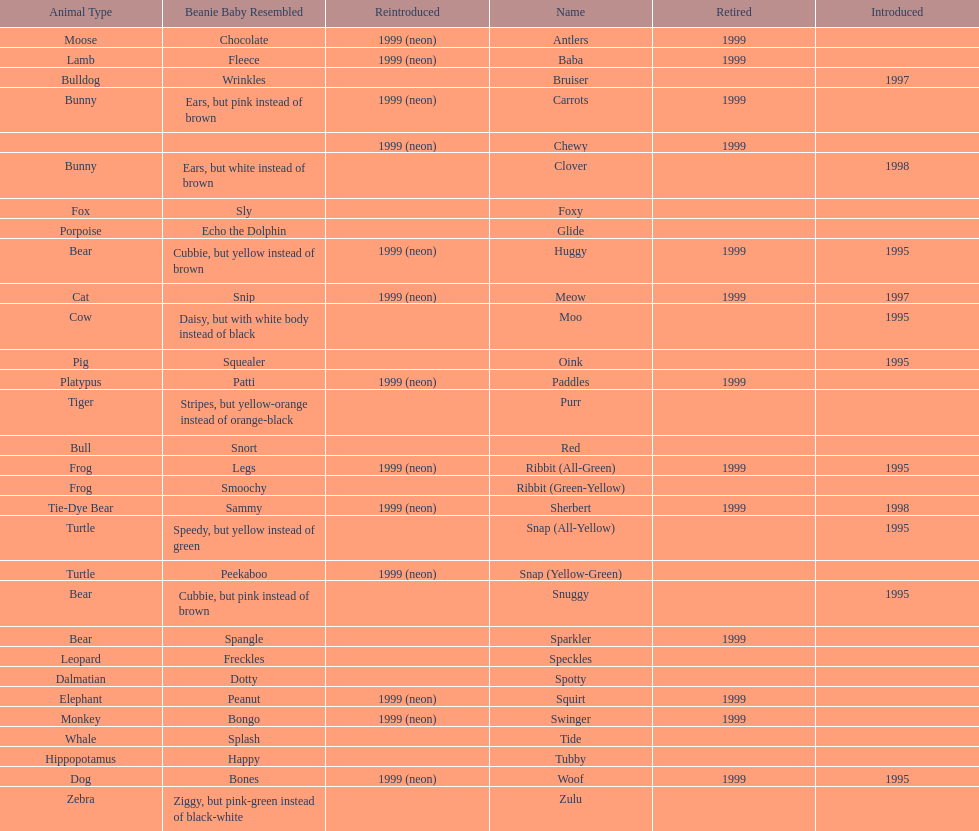What was the duration of woof the dog being sold before its retirement? 4 years. 